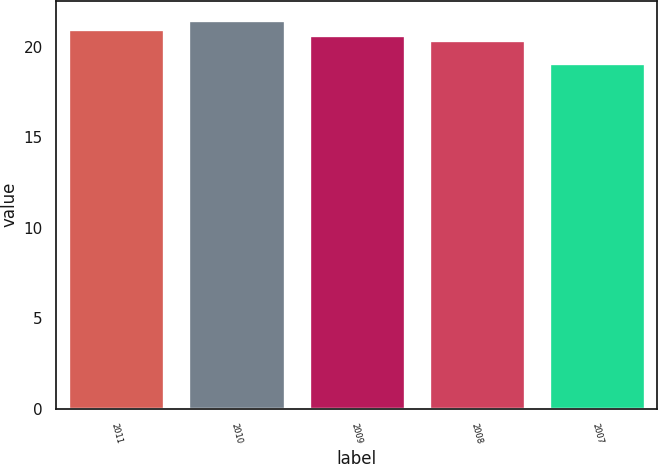Convert chart. <chart><loc_0><loc_0><loc_500><loc_500><bar_chart><fcel>2011<fcel>2010<fcel>2009<fcel>2008<fcel>2007<nl><fcel>20.99<fcel>21.47<fcel>20.67<fcel>20.38<fcel>19.11<nl></chart> 